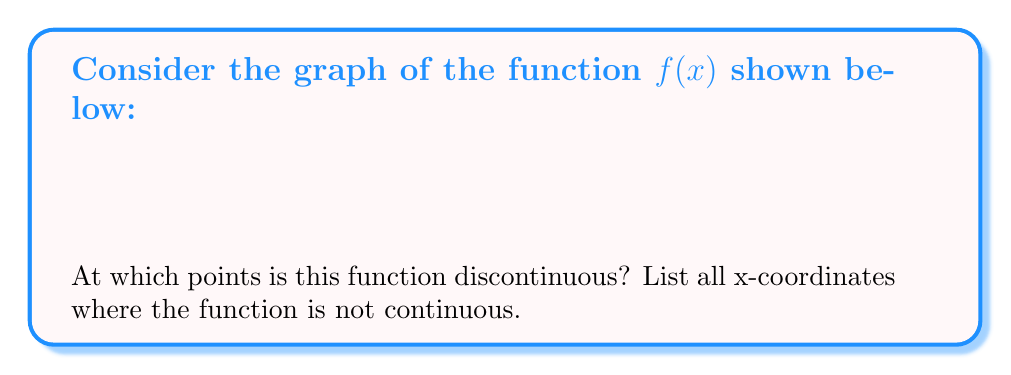Give your solution to this math problem. To find points of discontinuity, we need to look for places where the function is not continuous. A function is continuous at a point if:

1. The function is defined at that point
2. The limit of the function exists as we approach the point from both sides
3. The limit equals the function value at that point

Let's examine the graph:

1. At $x = 0$:
   - The function is defined (the graph has a point here)
   - The left limit equals the right limit (the line passes through this point)
   - The limit equals the function value
   Therefore, the function is continuous at $x = 0$

2. At $x = 2$:
   - The function is defined for all values up to 2
   - The left limit as x approaches 2 is 2
   - The right limit as x approaches 2 is 3
   - These limits are not equal, so there's a jump discontinuity at $x = 2$

3. For all other points:
   - The function appears to be continuous (no breaks or jumps in the graph)

Therefore, the only point of discontinuity is at $x = 2$.
Answer: $x = 2$ 